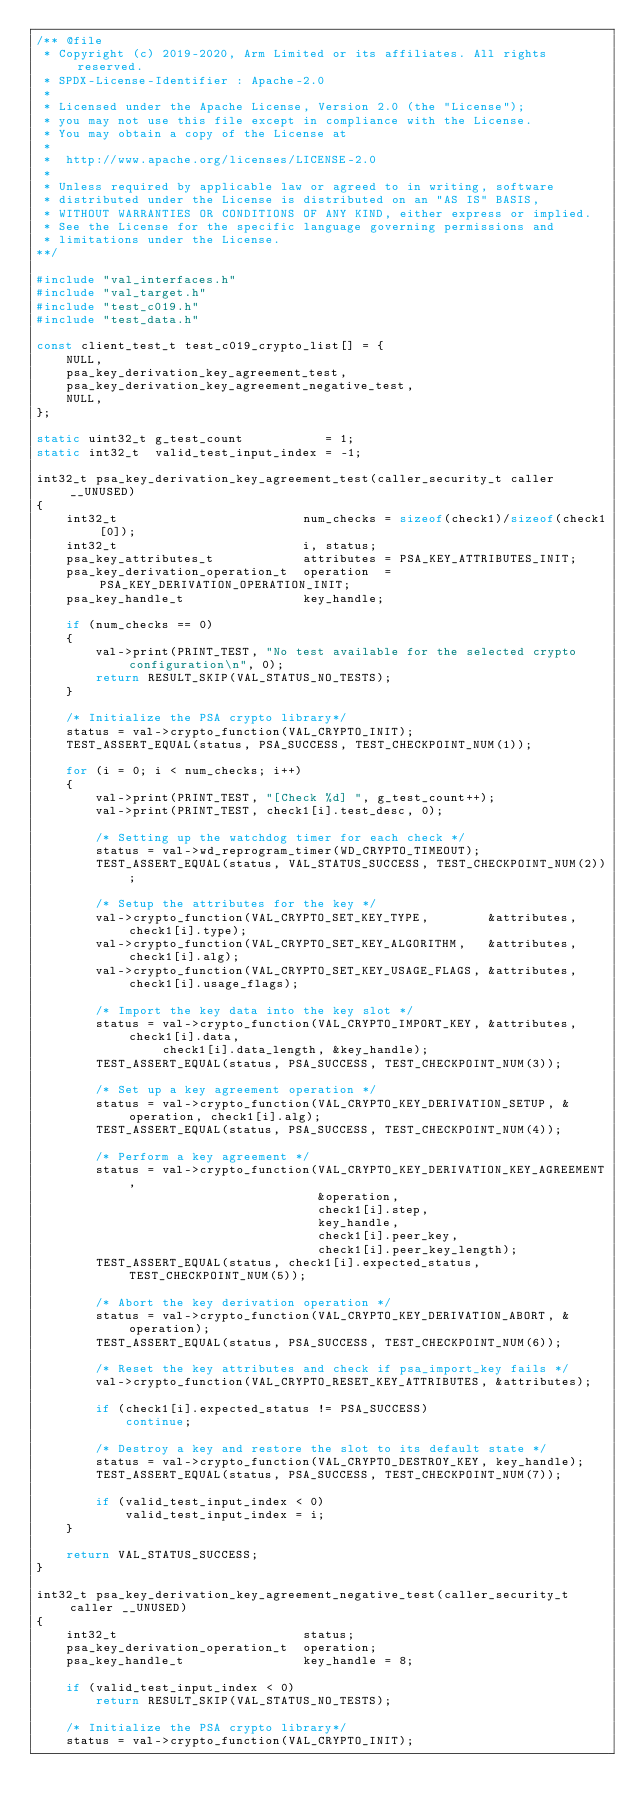<code> <loc_0><loc_0><loc_500><loc_500><_C_>/** @file
 * Copyright (c) 2019-2020, Arm Limited or its affiliates. All rights reserved.
 * SPDX-License-Identifier : Apache-2.0
 *
 * Licensed under the Apache License, Version 2.0 (the "License");
 * you may not use this file except in compliance with the License.
 * You may obtain a copy of the License at
 *
 *  http://www.apache.org/licenses/LICENSE-2.0
 *
 * Unless required by applicable law or agreed to in writing, software
 * distributed under the License is distributed on an "AS IS" BASIS,
 * WITHOUT WARRANTIES OR CONDITIONS OF ANY KIND, either express or implied.
 * See the License for the specific language governing permissions and
 * limitations under the License.
**/

#include "val_interfaces.h"
#include "val_target.h"
#include "test_c019.h"
#include "test_data.h"

const client_test_t test_c019_crypto_list[] = {
    NULL,
    psa_key_derivation_key_agreement_test,
    psa_key_derivation_key_agreement_negative_test,
    NULL,
};

static uint32_t g_test_count           = 1;
static int32_t  valid_test_input_index = -1;

int32_t psa_key_derivation_key_agreement_test(caller_security_t caller __UNUSED)
{
    int32_t                         num_checks = sizeof(check1)/sizeof(check1[0]);
    int32_t                         i, status;
    psa_key_attributes_t            attributes = PSA_KEY_ATTRIBUTES_INIT;
    psa_key_derivation_operation_t  operation  = PSA_KEY_DERIVATION_OPERATION_INIT;
    psa_key_handle_t                key_handle;

    if (num_checks == 0)
    {
        val->print(PRINT_TEST, "No test available for the selected crypto configuration\n", 0);
        return RESULT_SKIP(VAL_STATUS_NO_TESTS);
    }

    /* Initialize the PSA crypto library*/
    status = val->crypto_function(VAL_CRYPTO_INIT);
    TEST_ASSERT_EQUAL(status, PSA_SUCCESS, TEST_CHECKPOINT_NUM(1));

    for (i = 0; i < num_checks; i++)
    {
        val->print(PRINT_TEST, "[Check %d] ", g_test_count++);
        val->print(PRINT_TEST, check1[i].test_desc, 0);

        /* Setting up the watchdog timer for each check */
        status = val->wd_reprogram_timer(WD_CRYPTO_TIMEOUT);
        TEST_ASSERT_EQUAL(status, VAL_STATUS_SUCCESS, TEST_CHECKPOINT_NUM(2));

        /* Setup the attributes for the key */
        val->crypto_function(VAL_CRYPTO_SET_KEY_TYPE,        &attributes, check1[i].type);
        val->crypto_function(VAL_CRYPTO_SET_KEY_ALGORITHM,   &attributes, check1[i].alg);
        val->crypto_function(VAL_CRYPTO_SET_KEY_USAGE_FLAGS, &attributes, check1[i].usage_flags);

        /* Import the key data into the key slot */
        status = val->crypto_function(VAL_CRYPTO_IMPORT_KEY, &attributes, check1[i].data,
                 check1[i].data_length, &key_handle);
        TEST_ASSERT_EQUAL(status, PSA_SUCCESS, TEST_CHECKPOINT_NUM(3));

        /* Set up a key agreement operation */
        status = val->crypto_function(VAL_CRYPTO_KEY_DERIVATION_SETUP, &operation, check1[i].alg);
        TEST_ASSERT_EQUAL(status, PSA_SUCCESS, TEST_CHECKPOINT_NUM(4));

        /* Perform a key agreement */
        status = val->crypto_function(VAL_CRYPTO_KEY_DERIVATION_KEY_AGREEMENT,
                                      &operation,
                                      check1[i].step,
                                      key_handle,
                                      check1[i].peer_key,
                                      check1[i].peer_key_length);
        TEST_ASSERT_EQUAL(status, check1[i].expected_status, TEST_CHECKPOINT_NUM(5));

        /* Abort the key derivation operation */
        status = val->crypto_function(VAL_CRYPTO_KEY_DERIVATION_ABORT, &operation);
        TEST_ASSERT_EQUAL(status, PSA_SUCCESS, TEST_CHECKPOINT_NUM(6));

        /* Reset the key attributes and check if psa_import_key fails */
        val->crypto_function(VAL_CRYPTO_RESET_KEY_ATTRIBUTES, &attributes);

        if (check1[i].expected_status != PSA_SUCCESS)
            continue;

        /* Destroy a key and restore the slot to its default state */
        status = val->crypto_function(VAL_CRYPTO_DESTROY_KEY, key_handle);
        TEST_ASSERT_EQUAL(status, PSA_SUCCESS, TEST_CHECKPOINT_NUM(7));

        if (valid_test_input_index < 0)
            valid_test_input_index = i;
    }

    return VAL_STATUS_SUCCESS;
}

int32_t psa_key_derivation_key_agreement_negative_test(caller_security_t caller __UNUSED)
{
    int32_t                         status;
    psa_key_derivation_operation_t  operation;
    psa_key_handle_t                key_handle = 8;

    if (valid_test_input_index < 0)
        return RESULT_SKIP(VAL_STATUS_NO_TESTS);

    /* Initialize the PSA crypto library*/
    status = val->crypto_function(VAL_CRYPTO_INIT);</code> 